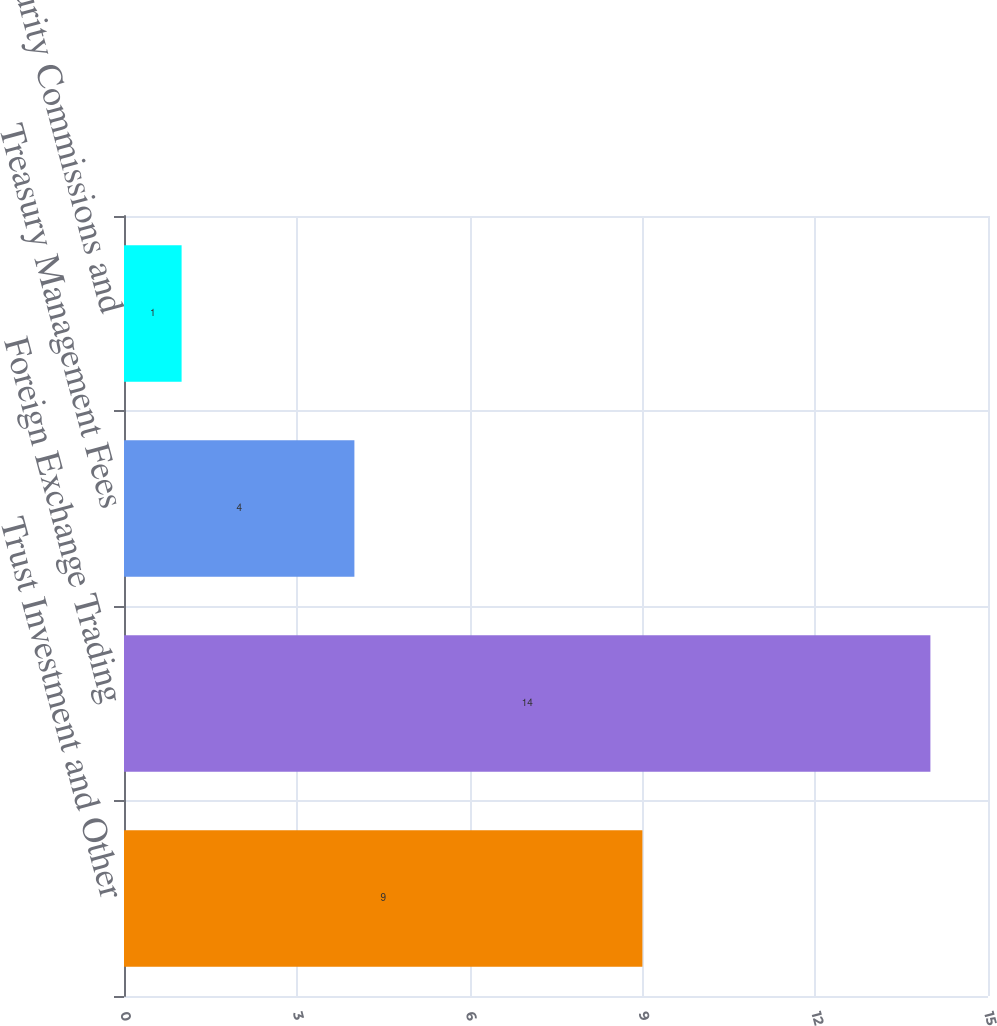Convert chart. <chart><loc_0><loc_0><loc_500><loc_500><bar_chart><fcel>Trust Investment and Other<fcel>Foreign Exchange Trading<fcel>Treasury Management Fees<fcel>Security Commissions and<nl><fcel>9<fcel>14<fcel>4<fcel>1<nl></chart> 